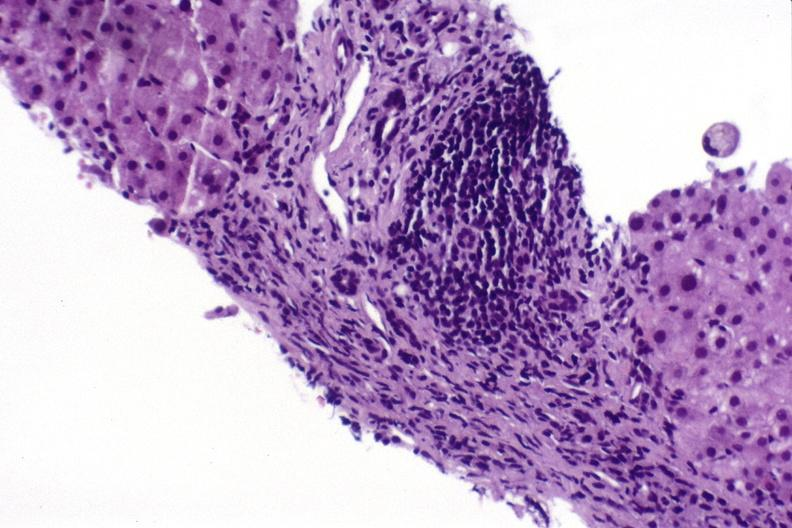does good example of muscle atrophy show hepatitis c virus?
Answer the question using a single word or phrase. No 